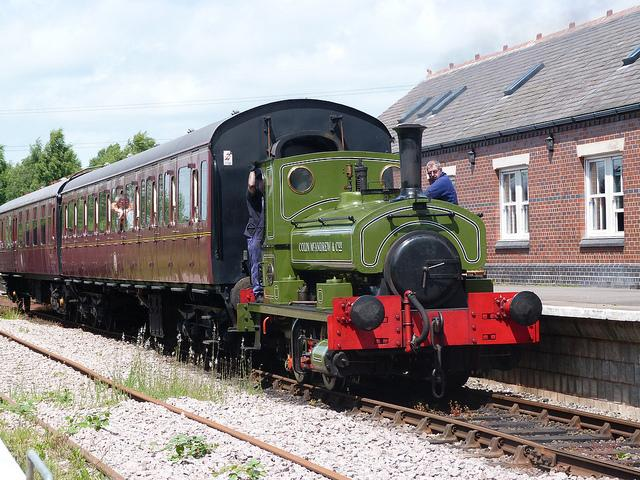What years was this machine first introduced?

Choices:
A) 1866
B) 2004
C) 1994
D) 1804 1804 